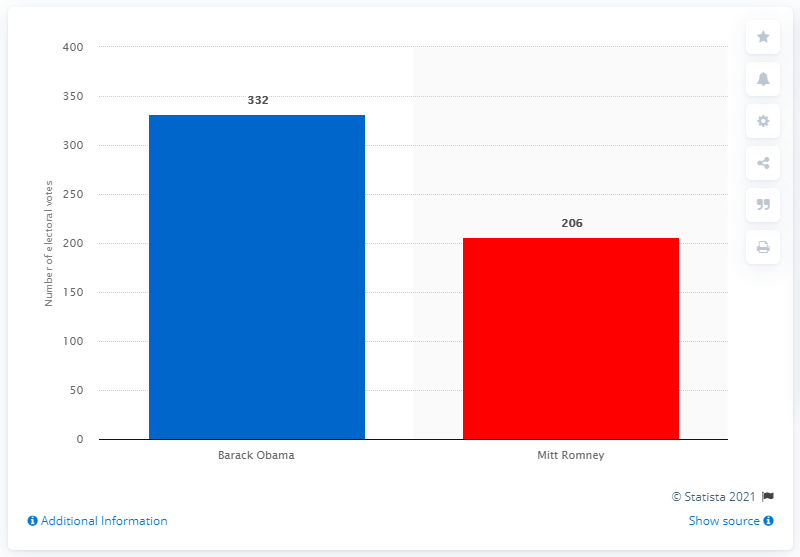Specify some key components in this picture. In the 2012 presidential election, Mitt Romney received 206 electoral votes. In the 2012 election, President Barack Obama received 332 votes. 